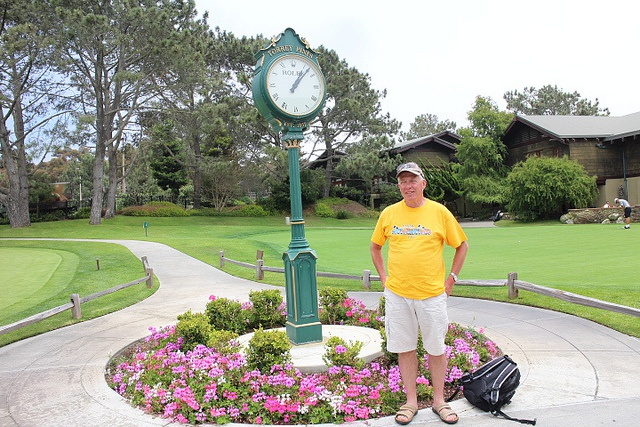Describe the objects in this image and their specific colors. I can see people in gray, gold, lightgray, lightpink, and orange tones, clock in gray, lightgray, darkgray, and teal tones, backpack in gray, black, and lavender tones, potted plant in gray, olive, darkgreen, and black tones, and potted plant in gray, darkgreen, olive, black, and white tones in this image. 